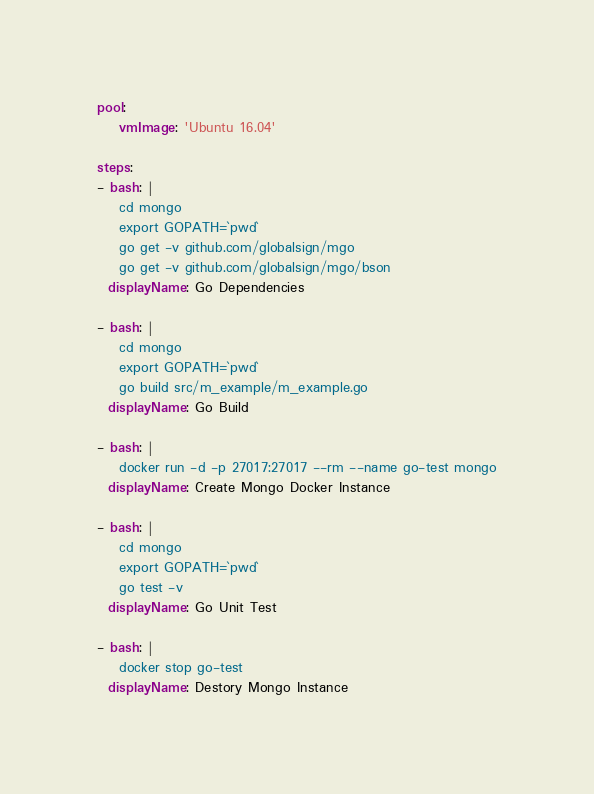<code> <loc_0><loc_0><loc_500><loc_500><_YAML_>pool:
    vmImage: 'Ubuntu 16.04'

steps:
- bash: |
    cd mongo 
    export GOPATH=`pwd` 
    go get -v github.com/globalsign/mgo
    go get -v github.com/globalsign/mgo/bson 
  displayName: Go Dependencies 

- bash: |
    cd mongo 
    export GOPATH=`pwd` 
    go build src/m_example/m_example.go
  displayName: Go Build

- bash: |
    docker run -d -p 27017:27017 --rm --name go-test mongo
  displayName: Create Mongo Docker Instance 

- bash: |
    cd mongo 
    export GOPATH=`pwd` 
    go test -v
  displayName: Go Unit Test

- bash: |
    docker stop go-test
  displayName: Destory Mongo Instance</code> 